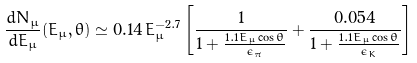Convert formula to latex. <formula><loc_0><loc_0><loc_500><loc_500>\frac { d N _ { \mu } } { d E _ { \mu } } ( E _ { \mu } , \theta ) \simeq 0 . 1 4 \, E _ { \mu } ^ { - 2 . 7 } \left [ \frac { 1 } { 1 + \frac { 1 . 1 E _ { \mu } \cos \theta } { \epsilon _ { \pi } } } + \frac { 0 . 0 5 4 } { 1 + \frac { 1 . 1 E _ { \mu } \cos \theta } { \epsilon _ { K } } } \right ]</formula> 